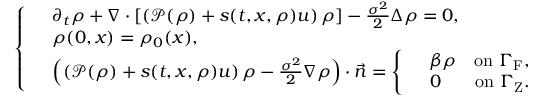Convert formula to latex. <formula><loc_0><loc_0><loc_500><loc_500>\left \{ \begin{array} { r l } & { \partial _ { t } \rho + \nabla \cdot \left [ \left ( \mathcal { P } ( \rho ) + s ( t , x , \rho ) u \right ) \rho \right ] - \frac { \sigma ^ { 2 } } { 2 } \Delta \rho = 0 , } \\ & { \rho ( 0 , x ) = \rho _ { 0 } ( x ) , } \\ & { \left ( \left ( \mathcal { P } ( \rho ) + s ( t , x , \rho ) u \right ) \rho - \frac { \sigma ^ { 2 } } { 2 } \nabla \rho \right ) \cdot \vec { n } = \left \{ \begin{array} { r l r } & { \beta \rho } & { o n \Gamma _ { F } , } \\ & { 0 } & { o n \Gamma _ { Z } . } \end{array} } \end{array}</formula> 